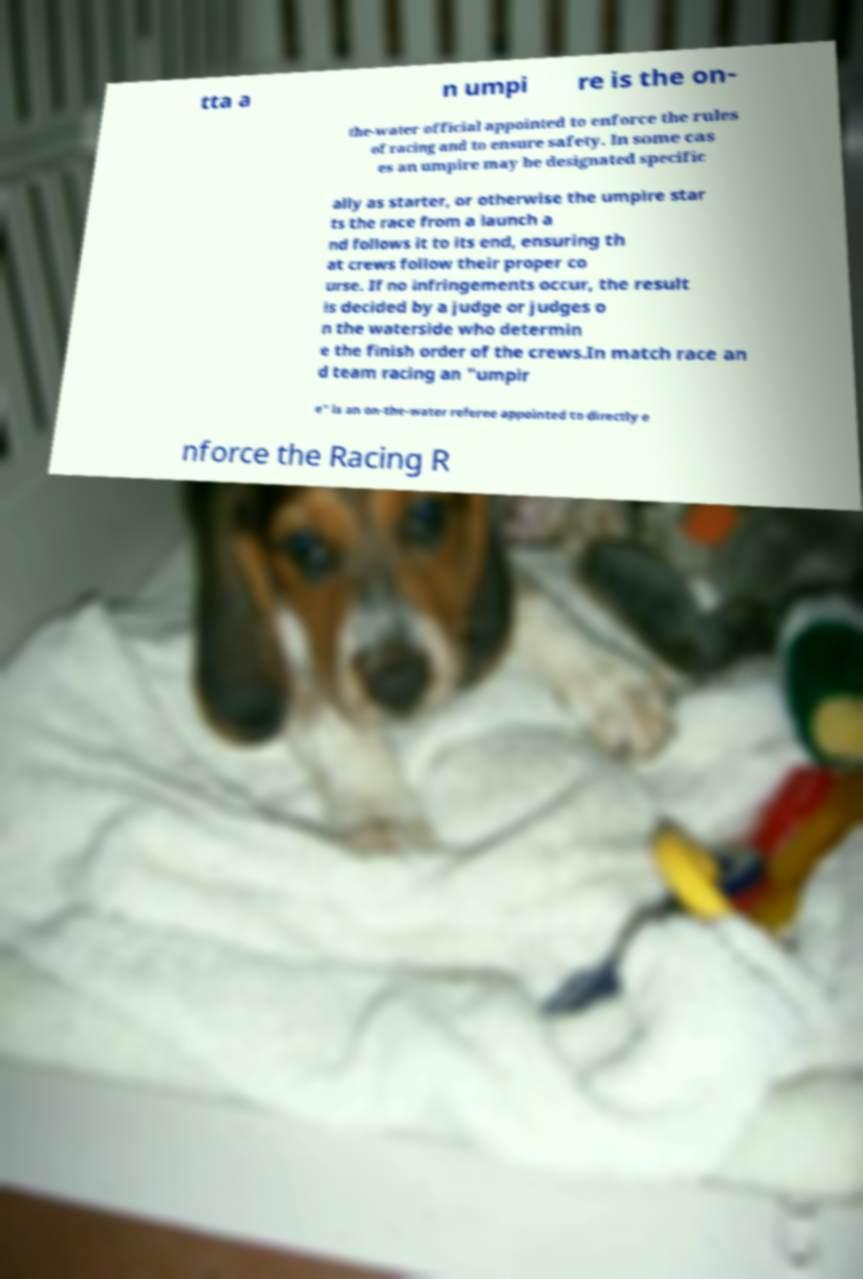What messages or text are displayed in this image? I need them in a readable, typed format. tta a n umpi re is the on- the-water official appointed to enforce the rules of racing and to ensure safety. In some cas es an umpire may be designated specific ally as starter, or otherwise the umpire star ts the race from a launch a nd follows it to its end, ensuring th at crews follow their proper co urse. If no infringements occur, the result is decided by a judge or judges o n the waterside who determin e the finish order of the crews.In match race an d team racing an "umpir e" is an on-the-water referee appointed to directly e nforce the Racing R 